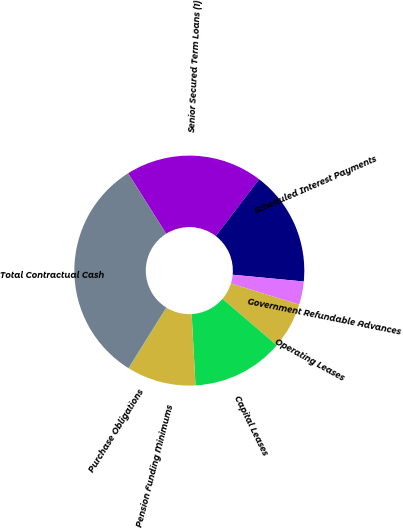Convert chart to OTSL. <chart><loc_0><loc_0><loc_500><loc_500><pie_chart><fcel>Senior Secured Term Loans (1)<fcel>Scheduled Interest Payments<fcel>Government Refundable Advances<fcel>Operating Leases<fcel>Capital Leases<fcel>Pension Funding Minimums<fcel>Purchase Obligations<fcel>Total Contractual Cash<nl><fcel>19.33%<fcel>16.12%<fcel>3.26%<fcel>6.47%<fcel>12.9%<fcel>9.69%<fcel>0.05%<fcel>32.18%<nl></chart> 